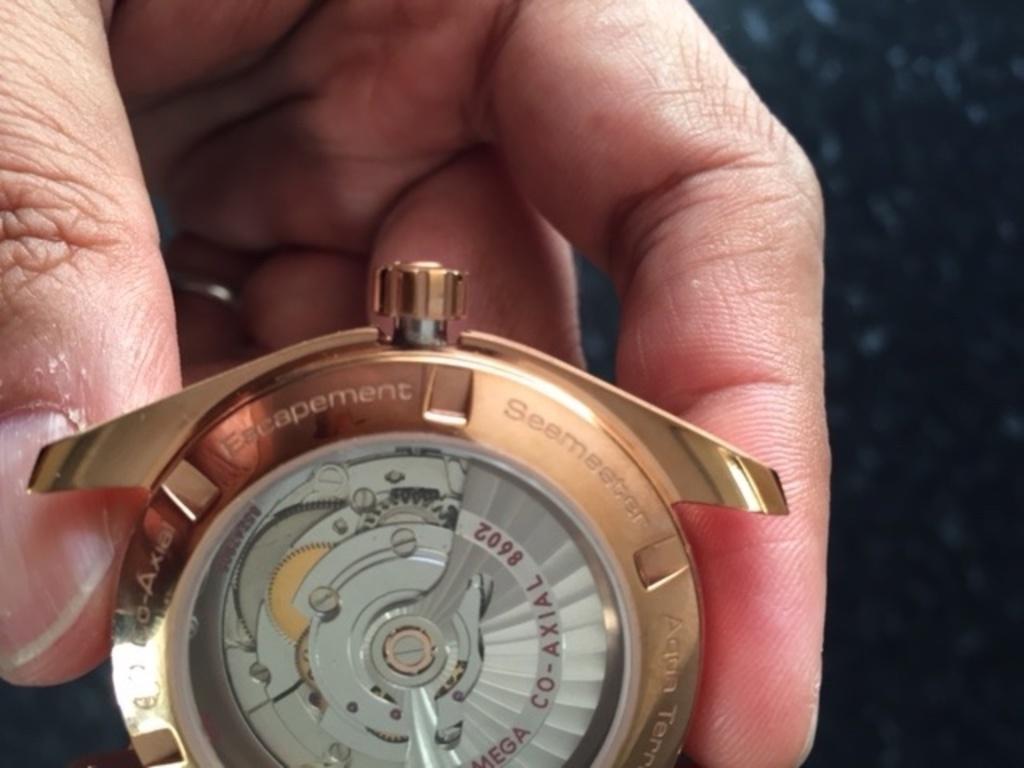Can you name a feature of the watch?
Give a very brief answer. Escapement. 